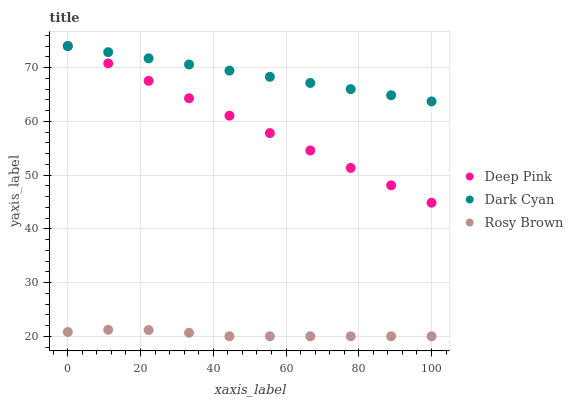Does Rosy Brown have the minimum area under the curve?
Answer yes or no. Yes. Does Dark Cyan have the maximum area under the curve?
Answer yes or no. Yes. Does Deep Pink have the minimum area under the curve?
Answer yes or no. No. Does Deep Pink have the maximum area under the curve?
Answer yes or no. No. Is Deep Pink the smoothest?
Answer yes or no. Yes. Is Rosy Brown the roughest?
Answer yes or no. Yes. Is Rosy Brown the smoothest?
Answer yes or no. No. Is Deep Pink the roughest?
Answer yes or no. No. Does Rosy Brown have the lowest value?
Answer yes or no. Yes. Does Deep Pink have the lowest value?
Answer yes or no. No. Does Deep Pink have the highest value?
Answer yes or no. Yes. Does Rosy Brown have the highest value?
Answer yes or no. No. Is Rosy Brown less than Deep Pink?
Answer yes or no. Yes. Is Deep Pink greater than Rosy Brown?
Answer yes or no. Yes. Does Deep Pink intersect Dark Cyan?
Answer yes or no. Yes. Is Deep Pink less than Dark Cyan?
Answer yes or no. No. Is Deep Pink greater than Dark Cyan?
Answer yes or no. No. Does Rosy Brown intersect Deep Pink?
Answer yes or no. No. 